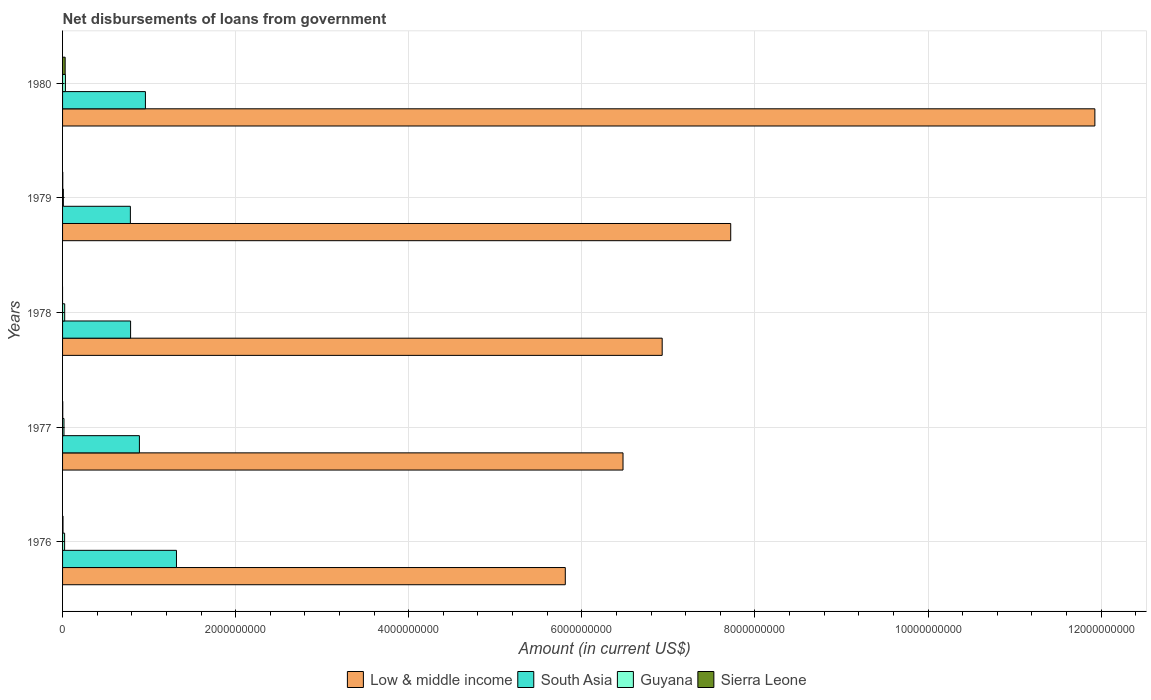How many groups of bars are there?
Ensure brevity in your answer.  5. Are the number of bars on each tick of the Y-axis equal?
Make the answer very short. No. How many bars are there on the 5th tick from the top?
Your response must be concise. 4. What is the label of the 3rd group of bars from the top?
Make the answer very short. 1978. What is the amount of loan disbursed from government in Guyana in 1977?
Your response must be concise. 1.63e+07. Across all years, what is the maximum amount of loan disbursed from government in Low & middle income?
Keep it short and to the point. 1.19e+1. Across all years, what is the minimum amount of loan disbursed from government in Guyana?
Offer a very short reply. 9.15e+06. What is the total amount of loan disbursed from government in Guyana in the graph?
Give a very brief answer. 1.07e+08. What is the difference between the amount of loan disbursed from government in Guyana in 1976 and that in 1977?
Your answer should be compact. 7.32e+06. What is the difference between the amount of loan disbursed from government in South Asia in 1977 and the amount of loan disbursed from government in Sierra Leone in 1976?
Provide a succinct answer. 8.83e+08. What is the average amount of loan disbursed from government in Sierra Leone per year?
Your answer should be very brief. 7.88e+06. In the year 1980, what is the difference between the amount of loan disbursed from government in Sierra Leone and amount of loan disbursed from government in South Asia?
Keep it short and to the point. -9.27e+08. In how many years, is the amount of loan disbursed from government in Low & middle income greater than 10000000000 US$?
Your response must be concise. 1. What is the ratio of the amount of loan disbursed from government in Low & middle income in 1977 to that in 1979?
Give a very brief answer. 0.84. Is the amount of loan disbursed from government in Sierra Leone in 1976 less than that in 1979?
Your response must be concise. No. What is the difference between the highest and the second highest amount of loan disbursed from government in Low & middle income?
Provide a succinct answer. 4.21e+09. What is the difference between the highest and the lowest amount of loan disbursed from government in South Asia?
Give a very brief answer. 5.33e+08. In how many years, is the amount of loan disbursed from government in Sierra Leone greater than the average amount of loan disbursed from government in Sierra Leone taken over all years?
Offer a terse response. 1. How many bars are there?
Give a very brief answer. 19. How many years are there in the graph?
Ensure brevity in your answer.  5. Where does the legend appear in the graph?
Make the answer very short. Bottom center. How many legend labels are there?
Provide a succinct answer. 4. How are the legend labels stacked?
Provide a short and direct response. Horizontal. What is the title of the graph?
Provide a succinct answer. Net disbursements of loans from government. Does "St. Lucia" appear as one of the legend labels in the graph?
Give a very brief answer. No. What is the label or title of the X-axis?
Keep it short and to the point. Amount (in current US$). What is the label or title of the Y-axis?
Offer a terse response. Years. What is the Amount (in current US$) of Low & middle income in 1976?
Keep it short and to the point. 5.81e+09. What is the Amount (in current US$) of South Asia in 1976?
Give a very brief answer. 1.32e+09. What is the Amount (in current US$) in Guyana in 1976?
Give a very brief answer. 2.36e+07. What is the Amount (in current US$) in Sierra Leone in 1976?
Your response must be concise. 5.00e+06. What is the Amount (in current US$) of Low & middle income in 1977?
Provide a succinct answer. 6.48e+09. What is the Amount (in current US$) in South Asia in 1977?
Keep it short and to the point. 8.88e+08. What is the Amount (in current US$) of Guyana in 1977?
Give a very brief answer. 1.63e+07. What is the Amount (in current US$) in Sierra Leone in 1977?
Offer a terse response. 2.13e+06. What is the Amount (in current US$) of Low & middle income in 1978?
Make the answer very short. 6.93e+09. What is the Amount (in current US$) of South Asia in 1978?
Keep it short and to the point. 7.86e+08. What is the Amount (in current US$) in Guyana in 1978?
Your answer should be compact. 2.44e+07. What is the Amount (in current US$) in Sierra Leone in 1978?
Ensure brevity in your answer.  0. What is the Amount (in current US$) of Low & middle income in 1979?
Provide a succinct answer. 7.72e+09. What is the Amount (in current US$) in South Asia in 1979?
Keep it short and to the point. 7.83e+08. What is the Amount (in current US$) in Guyana in 1979?
Provide a short and direct response. 9.15e+06. What is the Amount (in current US$) in Sierra Leone in 1979?
Offer a very short reply. 2.27e+06. What is the Amount (in current US$) of Low & middle income in 1980?
Offer a terse response. 1.19e+1. What is the Amount (in current US$) in South Asia in 1980?
Provide a short and direct response. 9.57e+08. What is the Amount (in current US$) of Guyana in 1980?
Keep it short and to the point. 3.30e+07. What is the Amount (in current US$) of Sierra Leone in 1980?
Offer a very short reply. 3.00e+07. Across all years, what is the maximum Amount (in current US$) in Low & middle income?
Ensure brevity in your answer.  1.19e+1. Across all years, what is the maximum Amount (in current US$) in South Asia?
Give a very brief answer. 1.32e+09. Across all years, what is the maximum Amount (in current US$) of Guyana?
Provide a succinct answer. 3.30e+07. Across all years, what is the maximum Amount (in current US$) of Sierra Leone?
Make the answer very short. 3.00e+07. Across all years, what is the minimum Amount (in current US$) in Low & middle income?
Ensure brevity in your answer.  5.81e+09. Across all years, what is the minimum Amount (in current US$) in South Asia?
Offer a terse response. 7.83e+08. Across all years, what is the minimum Amount (in current US$) in Guyana?
Give a very brief answer. 9.15e+06. What is the total Amount (in current US$) of Low & middle income in the graph?
Provide a succinct answer. 3.89e+1. What is the total Amount (in current US$) of South Asia in the graph?
Offer a very short reply. 4.73e+09. What is the total Amount (in current US$) in Guyana in the graph?
Your answer should be compact. 1.07e+08. What is the total Amount (in current US$) in Sierra Leone in the graph?
Provide a succinct answer. 3.94e+07. What is the difference between the Amount (in current US$) in Low & middle income in 1976 and that in 1977?
Your response must be concise. -6.67e+08. What is the difference between the Amount (in current US$) of South Asia in 1976 and that in 1977?
Keep it short and to the point. 4.28e+08. What is the difference between the Amount (in current US$) in Guyana in 1976 and that in 1977?
Ensure brevity in your answer.  7.32e+06. What is the difference between the Amount (in current US$) in Sierra Leone in 1976 and that in 1977?
Your response must be concise. 2.87e+06. What is the difference between the Amount (in current US$) in Low & middle income in 1976 and that in 1978?
Your answer should be compact. -1.12e+09. What is the difference between the Amount (in current US$) of South Asia in 1976 and that in 1978?
Give a very brief answer. 5.30e+08. What is the difference between the Amount (in current US$) in Guyana in 1976 and that in 1978?
Offer a very short reply. -8.11e+05. What is the difference between the Amount (in current US$) of Low & middle income in 1976 and that in 1979?
Provide a succinct answer. -1.91e+09. What is the difference between the Amount (in current US$) of South Asia in 1976 and that in 1979?
Provide a succinct answer. 5.33e+08. What is the difference between the Amount (in current US$) in Guyana in 1976 and that in 1979?
Make the answer very short. 1.45e+07. What is the difference between the Amount (in current US$) of Sierra Leone in 1976 and that in 1979?
Keep it short and to the point. 2.73e+06. What is the difference between the Amount (in current US$) in Low & middle income in 1976 and that in 1980?
Keep it short and to the point. -6.12e+09. What is the difference between the Amount (in current US$) in South Asia in 1976 and that in 1980?
Provide a short and direct response. 3.59e+08. What is the difference between the Amount (in current US$) in Guyana in 1976 and that in 1980?
Give a very brief answer. -9.32e+06. What is the difference between the Amount (in current US$) in Sierra Leone in 1976 and that in 1980?
Ensure brevity in your answer.  -2.50e+07. What is the difference between the Amount (in current US$) in Low & middle income in 1977 and that in 1978?
Keep it short and to the point. -4.53e+08. What is the difference between the Amount (in current US$) of South Asia in 1977 and that in 1978?
Keep it short and to the point. 1.02e+08. What is the difference between the Amount (in current US$) in Guyana in 1977 and that in 1978?
Make the answer very short. -8.13e+06. What is the difference between the Amount (in current US$) in Low & middle income in 1977 and that in 1979?
Your response must be concise. -1.24e+09. What is the difference between the Amount (in current US$) in South Asia in 1977 and that in 1979?
Keep it short and to the point. 1.04e+08. What is the difference between the Amount (in current US$) of Guyana in 1977 and that in 1979?
Keep it short and to the point. 7.16e+06. What is the difference between the Amount (in current US$) of Sierra Leone in 1977 and that in 1979?
Your response must be concise. -1.42e+05. What is the difference between the Amount (in current US$) of Low & middle income in 1977 and that in 1980?
Give a very brief answer. -5.45e+09. What is the difference between the Amount (in current US$) in South Asia in 1977 and that in 1980?
Your answer should be compact. -6.96e+07. What is the difference between the Amount (in current US$) in Guyana in 1977 and that in 1980?
Offer a terse response. -1.66e+07. What is the difference between the Amount (in current US$) of Sierra Leone in 1977 and that in 1980?
Provide a succinct answer. -2.79e+07. What is the difference between the Amount (in current US$) of Low & middle income in 1978 and that in 1979?
Keep it short and to the point. -7.92e+08. What is the difference between the Amount (in current US$) in South Asia in 1978 and that in 1979?
Offer a very short reply. 2.49e+06. What is the difference between the Amount (in current US$) of Guyana in 1978 and that in 1979?
Your answer should be very brief. 1.53e+07. What is the difference between the Amount (in current US$) of Low & middle income in 1978 and that in 1980?
Offer a very short reply. -5.00e+09. What is the difference between the Amount (in current US$) of South Asia in 1978 and that in 1980?
Give a very brief answer. -1.71e+08. What is the difference between the Amount (in current US$) of Guyana in 1978 and that in 1980?
Make the answer very short. -8.51e+06. What is the difference between the Amount (in current US$) of Low & middle income in 1979 and that in 1980?
Your response must be concise. -4.21e+09. What is the difference between the Amount (in current US$) of South Asia in 1979 and that in 1980?
Ensure brevity in your answer.  -1.74e+08. What is the difference between the Amount (in current US$) of Guyana in 1979 and that in 1980?
Your response must be concise. -2.38e+07. What is the difference between the Amount (in current US$) in Sierra Leone in 1979 and that in 1980?
Offer a very short reply. -2.77e+07. What is the difference between the Amount (in current US$) of Low & middle income in 1976 and the Amount (in current US$) of South Asia in 1977?
Your answer should be compact. 4.92e+09. What is the difference between the Amount (in current US$) in Low & middle income in 1976 and the Amount (in current US$) in Guyana in 1977?
Provide a succinct answer. 5.79e+09. What is the difference between the Amount (in current US$) of Low & middle income in 1976 and the Amount (in current US$) of Sierra Leone in 1977?
Give a very brief answer. 5.81e+09. What is the difference between the Amount (in current US$) of South Asia in 1976 and the Amount (in current US$) of Guyana in 1977?
Your answer should be very brief. 1.30e+09. What is the difference between the Amount (in current US$) of South Asia in 1976 and the Amount (in current US$) of Sierra Leone in 1977?
Offer a terse response. 1.31e+09. What is the difference between the Amount (in current US$) of Guyana in 1976 and the Amount (in current US$) of Sierra Leone in 1977?
Keep it short and to the point. 2.15e+07. What is the difference between the Amount (in current US$) in Low & middle income in 1976 and the Amount (in current US$) in South Asia in 1978?
Your response must be concise. 5.02e+09. What is the difference between the Amount (in current US$) of Low & middle income in 1976 and the Amount (in current US$) of Guyana in 1978?
Keep it short and to the point. 5.78e+09. What is the difference between the Amount (in current US$) in South Asia in 1976 and the Amount (in current US$) in Guyana in 1978?
Your response must be concise. 1.29e+09. What is the difference between the Amount (in current US$) in Low & middle income in 1976 and the Amount (in current US$) in South Asia in 1979?
Make the answer very short. 5.03e+09. What is the difference between the Amount (in current US$) in Low & middle income in 1976 and the Amount (in current US$) in Guyana in 1979?
Ensure brevity in your answer.  5.80e+09. What is the difference between the Amount (in current US$) in Low & middle income in 1976 and the Amount (in current US$) in Sierra Leone in 1979?
Your response must be concise. 5.81e+09. What is the difference between the Amount (in current US$) of South Asia in 1976 and the Amount (in current US$) of Guyana in 1979?
Offer a terse response. 1.31e+09. What is the difference between the Amount (in current US$) of South Asia in 1976 and the Amount (in current US$) of Sierra Leone in 1979?
Offer a very short reply. 1.31e+09. What is the difference between the Amount (in current US$) in Guyana in 1976 and the Amount (in current US$) in Sierra Leone in 1979?
Make the answer very short. 2.14e+07. What is the difference between the Amount (in current US$) of Low & middle income in 1976 and the Amount (in current US$) of South Asia in 1980?
Ensure brevity in your answer.  4.85e+09. What is the difference between the Amount (in current US$) in Low & middle income in 1976 and the Amount (in current US$) in Guyana in 1980?
Ensure brevity in your answer.  5.78e+09. What is the difference between the Amount (in current US$) of Low & middle income in 1976 and the Amount (in current US$) of Sierra Leone in 1980?
Offer a terse response. 5.78e+09. What is the difference between the Amount (in current US$) of South Asia in 1976 and the Amount (in current US$) of Guyana in 1980?
Your response must be concise. 1.28e+09. What is the difference between the Amount (in current US$) of South Asia in 1976 and the Amount (in current US$) of Sierra Leone in 1980?
Make the answer very short. 1.29e+09. What is the difference between the Amount (in current US$) of Guyana in 1976 and the Amount (in current US$) of Sierra Leone in 1980?
Your answer should be compact. -6.37e+06. What is the difference between the Amount (in current US$) of Low & middle income in 1977 and the Amount (in current US$) of South Asia in 1978?
Offer a terse response. 5.69e+09. What is the difference between the Amount (in current US$) of Low & middle income in 1977 and the Amount (in current US$) of Guyana in 1978?
Keep it short and to the point. 6.45e+09. What is the difference between the Amount (in current US$) in South Asia in 1977 and the Amount (in current US$) in Guyana in 1978?
Keep it short and to the point. 8.63e+08. What is the difference between the Amount (in current US$) of Low & middle income in 1977 and the Amount (in current US$) of South Asia in 1979?
Give a very brief answer. 5.69e+09. What is the difference between the Amount (in current US$) of Low & middle income in 1977 and the Amount (in current US$) of Guyana in 1979?
Offer a very short reply. 6.47e+09. What is the difference between the Amount (in current US$) in Low & middle income in 1977 and the Amount (in current US$) in Sierra Leone in 1979?
Provide a short and direct response. 6.47e+09. What is the difference between the Amount (in current US$) of South Asia in 1977 and the Amount (in current US$) of Guyana in 1979?
Provide a short and direct response. 8.79e+08. What is the difference between the Amount (in current US$) of South Asia in 1977 and the Amount (in current US$) of Sierra Leone in 1979?
Provide a short and direct response. 8.86e+08. What is the difference between the Amount (in current US$) in Guyana in 1977 and the Amount (in current US$) in Sierra Leone in 1979?
Your answer should be compact. 1.40e+07. What is the difference between the Amount (in current US$) of Low & middle income in 1977 and the Amount (in current US$) of South Asia in 1980?
Your answer should be very brief. 5.52e+09. What is the difference between the Amount (in current US$) of Low & middle income in 1977 and the Amount (in current US$) of Guyana in 1980?
Your answer should be very brief. 6.44e+09. What is the difference between the Amount (in current US$) in Low & middle income in 1977 and the Amount (in current US$) in Sierra Leone in 1980?
Ensure brevity in your answer.  6.45e+09. What is the difference between the Amount (in current US$) of South Asia in 1977 and the Amount (in current US$) of Guyana in 1980?
Your answer should be very brief. 8.55e+08. What is the difference between the Amount (in current US$) of South Asia in 1977 and the Amount (in current US$) of Sierra Leone in 1980?
Keep it short and to the point. 8.58e+08. What is the difference between the Amount (in current US$) of Guyana in 1977 and the Amount (in current US$) of Sierra Leone in 1980?
Your answer should be compact. -1.37e+07. What is the difference between the Amount (in current US$) in Low & middle income in 1978 and the Amount (in current US$) in South Asia in 1979?
Your answer should be very brief. 6.14e+09. What is the difference between the Amount (in current US$) in Low & middle income in 1978 and the Amount (in current US$) in Guyana in 1979?
Offer a very short reply. 6.92e+09. What is the difference between the Amount (in current US$) in Low & middle income in 1978 and the Amount (in current US$) in Sierra Leone in 1979?
Provide a succinct answer. 6.93e+09. What is the difference between the Amount (in current US$) in South Asia in 1978 and the Amount (in current US$) in Guyana in 1979?
Keep it short and to the point. 7.77e+08. What is the difference between the Amount (in current US$) in South Asia in 1978 and the Amount (in current US$) in Sierra Leone in 1979?
Your response must be concise. 7.84e+08. What is the difference between the Amount (in current US$) of Guyana in 1978 and the Amount (in current US$) of Sierra Leone in 1979?
Ensure brevity in your answer.  2.22e+07. What is the difference between the Amount (in current US$) in Low & middle income in 1978 and the Amount (in current US$) in South Asia in 1980?
Provide a short and direct response. 5.97e+09. What is the difference between the Amount (in current US$) in Low & middle income in 1978 and the Amount (in current US$) in Guyana in 1980?
Keep it short and to the point. 6.90e+09. What is the difference between the Amount (in current US$) in Low & middle income in 1978 and the Amount (in current US$) in Sierra Leone in 1980?
Make the answer very short. 6.90e+09. What is the difference between the Amount (in current US$) of South Asia in 1978 and the Amount (in current US$) of Guyana in 1980?
Give a very brief answer. 7.53e+08. What is the difference between the Amount (in current US$) of South Asia in 1978 and the Amount (in current US$) of Sierra Leone in 1980?
Give a very brief answer. 7.56e+08. What is the difference between the Amount (in current US$) of Guyana in 1978 and the Amount (in current US$) of Sierra Leone in 1980?
Your answer should be very brief. -5.56e+06. What is the difference between the Amount (in current US$) of Low & middle income in 1979 and the Amount (in current US$) of South Asia in 1980?
Offer a terse response. 6.76e+09. What is the difference between the Amount (in current US$) in Low & middle income in 1979 and the Amount (in current US$) in Guyana in 1980?
Provide a succinct answer. 7.69e+09. What is the difference between the Amount (in current US$) of Low & middle income in 1979 and the Amount (in current US$) of Sierra Leone in 1980?
Give a very brief answer. 7.69e+09. What is the difference between the Amount (in current US$) of South Asia in 1979 and the Amount (in current US$) of Guyana in 1980?
Keep it short and to the point. 7.51e+08. What is the difference between the Amount (in current US$) of South Asia in 1979 and the Amount (in current US$) of Sierra Leone in 1980?
Keep it short and to the point. 7.53e+08. What is the difference between the Amount (in current US$) of Guyana in 1979 and the Amount (in current US$) of Sierra Leone in 1980?
Offer a very short reply. -2.09e+07. What is the average Amount (in current US$) in Low & middle income per year?
Offer a terse response. 7.77e+09. What is the average Amount (in current US$) in South Asia per year?
Your response must be concise. 9.46e+08. What is the average Amount (in current US$) of Guyana per year?
Your answer should be very brief. 2.13e+07. What is the average Amount (in current US$) of Sierra Leone per year?
Offer a very short reply. 7.88e+06. In the year 1976, what is the difference between the Amount (in current US$) of Low & middle income and Amount (in current US$) of South Asia?
Offer a terse response. 4.49e+09. In the year 1976, what is the difference between the Amount (in current US$) in Low & middle income and Amount (in current US$) in Guyana?
Offer a very short reply. 5.79e+09. In the year 1976, what is the difference between the Amount (in current US$) of Low & middle income and Amount (in current US$) of Sierra Leone?
Offer a terse response. 5.80e+09. In the year 1976, what is the difference between the Amount (in current US$) in South Asia and Amount (in current US$) in Guyana?
Your response must be concise. 1.29e+09. In the year 1976, what is the difference between the Amount (in current US$) of South Asia and Amount (in current US$) of Sierra Leone?
Ensure brevity in your answer.  1.31e+09. In the year 1976, what is the difference between the Amount (in current US$) in Guyana and Amount (in current US$) in Sierra Leone?
Provide a short and direct response. 1.86e+07. In the year 1977, what is the difference between the Amount (in current US$) of Low & middle income and Amount (in current US$) of South Asia?
Offer a very short reply. 5.59e+09. In the year 1977, what is the difference between the Amount (in current US$) of Low & middle income and Amount (in current US$) of Guyana?
Your response must be concise. 6.46e+09. In the year 1977, what is the difference between the Amount (in current US$) of Low & middle income and Amount (in current US$) of Sierra Leone?
Offer a very short reply. 6.47e+09. In the year 1977, what is the difference between the Amount (in current US$) in South Asia and Amount (in current US$) in Guyana?
Your answer should be very brief. 8.72e+08. In the year 1977, what is the difference between the Amount (in current US$) of South Asia and Amount (in current US$) of Sierra Leone?
Ensure brevity in your answer.  8.86e+08. In the year 1977, what is the difference between the Amount (in current US$) in Guyana and Amount (in current US$) in Sierra Leone?
Make the answer very short. 1.42e+07. In the year 1978, what is the difference between the Amount (in current US$) in Low & middle income and Amount (in current US$) in South Asia?
Offer a very short reply. 6.14e+09. In the year 1978, what is the difference between the Amount (in current US$) in Low & middle income and Amount (in current US$) in Guyana?
Offer a terse response. 6.90e+09. In the year 1978, what is the difference between the Amount (in current US$) of South Asia and Amount (in current US$) of Guyana?
Your answer should be very brief. 7.62e+08. In the year 1979, what is the difference between the Amount (in current US$) in Low & middle income and Amount (in current US$) in South Asia?
Give a very brief answer. 6.94e+09. In the year 1979, what is the difference between the Amount (in current US$) of Low & middle income and Amount (in current US$) of Guyana?
Keep it short and to the point. 7.71e+09. In the year 1979, what is the difference between the Amount (in current US$) in Low & middle income and Amount (in current US$) in Sierra Leone?
Give a very brief answer. 7.72e+09. In the year 1979, what is the difference between the Amount (in current US$) in South Asia and Amount (in current US$) in Guyana?
Your answer should be very brief. 7.74e+08. In the year 1979, what is the difference between the Amount (in current US$) of South Asia and Amount (in current US$) of Sierra Leone?
Keep it short and to the point. 7.81e+08. In the year 1979, what is the difference between the Amount (in current US$) in Guyana and Amount (in current US$) in Sierra Leone?
Your response must be concise. 6.88e+06. In the year 1980, what is the difference between the Amount (in current US$) in Low & middle income and Amount (in current US$) in South Asia?
Offer a very short reply. 1.10e+1. In the year 1980, what is the difference between the Amount (in current US$) of Low & middle income and Amount (in current US$) of Guyana?
Provide a short and direct response. 1.19e+1. In the year 1980, what is the difference between the Amount (in current US$) of Low & middle income and Amount (in current US$) of Sierra Leone?
Keep it short and to the point. 1.19e+1. In the year 1980, what is the difference between the Amount (in current US$) in South Asia and Amount (in current US$) in Guyana?
Your answer should be compact. 9.24e+08. In the year 1980, what is the difference between the Amount (in current US$) of South Asia and Amount (in current US$) of Sierra Leone?
Offer a terse response. 9.27e+08. In the year 1980, what is the difference between the Amount (in current US$) in Guyana and Amount (in current US$) in Sierra Leone?
Your answer should be compact. 2.95e+06. What is the ratio of the Amount (in current US$) in Low & middle income in 1976 to that in 1977?
Offer a terse response. 0.9. What is the ratio of the Amount (in current US$) of South Asia in 1976 to that in 1977?
Your answer should be compact. 1.48. What is the ratio of the Amount (in current US$) of Guyana in 1976 to that in 1977?
Make the answer very short. 1.45. What is the ratio of the Amount (in current US$) in Sierra Leone in 1976 to that in 1977?
Your answer should be compact. 2.35. What is the ratio of the Amount (in current US$) in Low & middle income in 1976 to that in 1978?
Your answer should be compact. 0.84. What is the ratio of the Amount (in current US$) in South Asia in 1976 to that in 1978?
Your answer should be compact. 1.67. What is the ratio of the Amount (in current US$) of Guyana in 1976 to that in 1978?
Make the answer very short. 0.97. What is the ratio of the Amount (in current US$) in Low & middle income in 1976 to that in 1979?
Keep it short and to the point. 0.75. What is the ratio of the Amount (in current US$) of South Asia in 1976 to that in 1979?
Your response must be concise. 1.68. What is the ratio of the Amount (in current US$) of Guyana in 1976 to that in 1979?
Offer a terse response. 2.58. What is the ratio of the Amount (in current US$) in Sierra Leone in 1976 to that in 1979?
Offer a terse response. 2.2. What is the ratio of the Amount (in current US$) of Low & middle income in 1976 to that in 1980?
Keep it short and to the point. 0.49. What is the ratio of the Amount (in current US$) in South Asia in 1976 to that in 1980?
Ensure brevity in your answer.  1.37. What is the ratio of the Amount (in current US$) of Guyana in 1976 to that in 1980?
Your answer should be very brief. 0.72. What is the ratio of the Amount (in current US$) in Sierra Leone in 1976 to that in 1980?
Give a very brief answer. 0.17. What is the ratio of the Amount (in current US$) of Low & middle income in 1977 to that in 1978?
Your answer should be very brief. 0.93. What is the ratio of the Amount (in current US$) in South Asia in 1977 to that in 1978?
Your response must be concise. 1.13. What is the ratio of the Amount (in current US$) in Guyana in 1977 to that in 1978?
Your response must be concise. 0.67. What is the ratio of the Amount (in current US$) of Low & middle income in 1977 to that in 1979?
Provide a short and direct response. 0.84. What is the ratio of the Amount (in current US$) of South Asia in 1977 to that in 1979?
Your response must be concise. 1.13. What is the ratio of the Amount (in current US$) in Guyana in 1977 to that in 1979?
Give a very brief answer. 1.78. What is the ratio of the Amount (in current US$) in Sierra Leone in 1977 to that in 1979?
Offer a very short reply. 0.94. What is the ratio of the Amount (in current US$) of Low & middle income in 1977 to that in 1980?
Offer a terse response. 0.54. What is the ratio of the Amount (in current US$) in South Asia in 1977 to that in 1980?
Your response must be concise. 0.93. What is the ratio of the Amount (in current US$) of Guyana in 1977 to that in 1980?
Offer a very short reply. 0.5. What is the ratio of the Amount (in current US$) of Sierra Leone in 1977 to that in 1980?
Ensure brevity in your answer.  0.07. What is the ratio of the Amount (in current US$) of Low & middle income in 1978 to that in 1979?
Keep it short and to the point. 0.9. What is the ratio of the Amount (in current US$) in South Asia in 1978 to that in 1979?
Make the answer very short. 1. What is the ratio of the Amount (in current US$) of Guyana in 1978 to that in 1979?
Give a very brief answer. 2.67. What is the ratio of the Amount (in current US$) of Low & middle income in 1978 to that in 1980?
Make the answer very short. 0.58. What is the ratio of the Amount (in current US$) of South Asia in 1978 to that in 1980?
Ensure brevity in your answer.  0.82. What is the ratio of the Amount (in current US$) in Guyana in 1978 to that in 1980?
Your answer should be compact. 0.74. What is the ratio of the Amount (in current US$) of Low & middle income in 1979 to that in 1980?
Make the answer very short. 0.65. What is the ratio of the Amount (in current US$) of South Asia in 1979 to that in 1980?
Your answer should be compact. 0.82. What is the ratio of the Amount (in current US$) in Guyana in 1979 to that in 1980?
Offer a terse response. 0.28. What is the ratio of the Amount (in current US$) in Sierra Leone in 1979 to that in 1980?
Make the answer very short. 0.08. What is the difference between the highest and the second highest Amount (in current US$) of Low & middle income?
Your answer should be very brief. 4.21e+09. What is the difference between the highest and the second highest Amount (in current US$) of South Asia?
Your answer should be compact. 3.59e+08. What is the difference between the highest and the second highest Amount (in current US$) of Guyana?
Keep it short and to the point. 8.51e+06. What is the difference between the highest and the second highest Amount (in current US$) in Sierra Leone?
Give a very brief answer. 2.50e+07. What is the difference between the highest and the lowest Amount (in current US$) of Low & middle income?
Your answer should be compact. 6.12e+09. What is the difference between the highest and the lowest Amount (in current US$) in South Asia?
Provide a short and direct response. 5.33e+08. What is the difference between the highest and the lowest Amount (in current US$) in Guyana?
Keep it short and to the point. 2.38e+07. What is the difference between the highest and the lowest Amount (in current US$) of Sierra Leone?
Provide a short and direct response. 3.00e+07. 